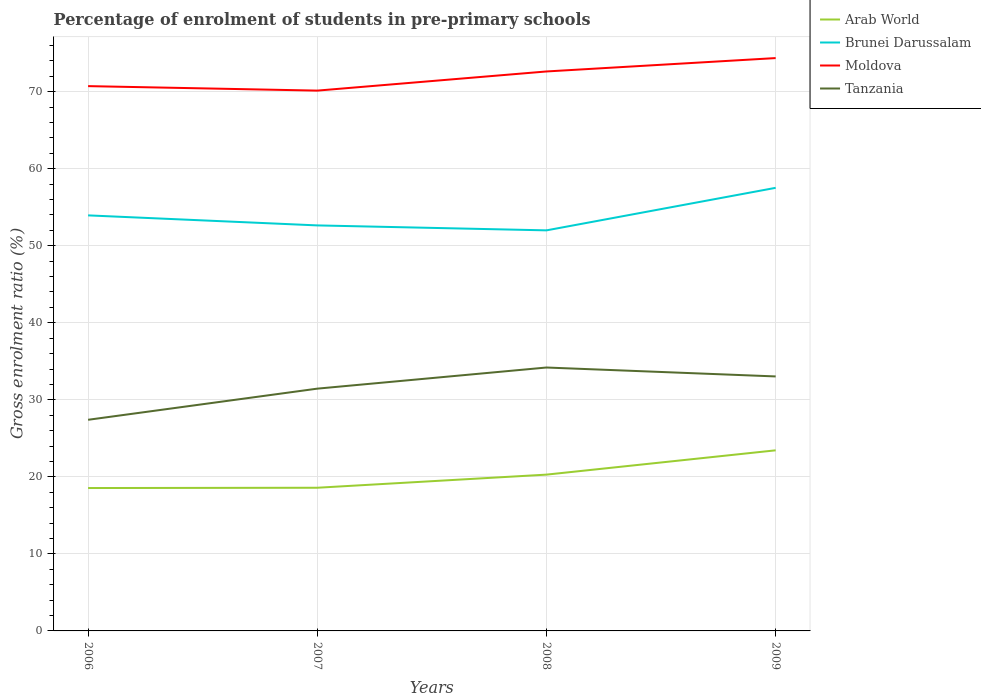Does the line corresponding to Moldova intersect with the line corresponding to Brunei Darussalam?
Your answer should be very brief. No. Is the number of lines equal to the number of legend labels?
Make the answer very short. Yes. Across all years, what is the maximum percentage of students enrolled in pre-primary schools in Arab World?
Provide a short and direct response. 18.55. What is the total percentage of students enrolled in pre-primary schools in Brunei Darussalam in the graph?
Give a very brief answer. 0.64. What is the difference between the highest and the second highest percentage of students enrolled in pre-primary schools in Moldova?
Keep it short and to the point. 4.22. What is the difference between the highest and the lowest percentage of students enrolled in pre-primary schools in Arab World?
Provide a short and direct response. 2. Does the graph contain any zero values?
Your answer should be compact. No. Where does the legend appear in the graph?
Offer a terse response. Top right. How many legend labels are there?
Give a very brief answer. 4. What is the title of the graph?
Offer a terse response. Percentage of enrolment of students in pre-primary schools. What is the label or title of the X-axis?
Ensure brevity in your answer.  Years. What is the Gross enrolment ratio (%) in Arab World in 2006?
Your response must be concise. 18.55. What is the Gross enrolment ratio (%) in Brunei Darussalam in 2006?
Your answer should be compact. 53.94. What is the Gross enrolment ratio (%) in Moldova in 2006?
Provide a succinct answer. 70.72. What is the Gross enrolment ratio (%) of Tanzania in 2006?
Your answer should be very brief. 27.41. What is the Gross enrolment ratio (%) of Arab World in 2007?
Your answer should be very brief. 18.59. What is the Gross enrolment ratio (%) of Brunei Darussalam in 2007?
Your answer should be very brief. 52.64. What is the Gross enrolment ratio (%) of Moldova in 2007?
Offer a very short reply. 70.14. What is the Gross enrolment ratio (%) of Tanzania in 2007?
Keep it short and to the point. 31.45. What is the Gross enrolment ratio (%) in Arab World in 2008?
Your answer should be very brief. 20.29. What is the Gross enrolment ratio (%) of Brunei Darussalam in 2008?
Offer a terse response. 52. What is the Gross enrolment ratio (%) in Moldova in 2008?
Your answer should be very brief. 72.63. What is the Gross enrolment ratio (%) in Tanzania in 2008?
Provide a short and direct response. 34.2. What is the Gross enrolment ratio (%) of Arab World in 2009?
Your answer should be compact. 23.45. What is the Gross enrolment ratio (%) of Brunei Darussalam in 2009?
Keep it short and to the point. 57.52. What is the Gross enrolment ratio (%) in Moldova in 2009?
Offer a terse response. 74.37. What is the Gross enrolment ratio (%) of Tanzania in 2009?
Offer a terse response. 33.04. Across all years, what is the maximum Gross enrolment ratio (%) of Arab World?
Offer a terse response. 23.45. Across all years, what is the maximum Gross enrolment ratio (%) in Brunei Darussalam?
Your response must be concise. 57.52. Across all years, what is the maximum Gross enrolment ratio (%) of Moldova?
Your response must be concise. 74.37. Across all years, what is the maximum Gross enrolment ratio (%) of Tanzania?
Keep it short and to the point. 34.2. Across all years, what is the minimum Gross enrolment ratio (%) of Arab World?
Provide a succinct answer. 18.55. Across all years, what is the minimum Gross enrolment ratio (%) in Brunei Darussalam?
Make the answer very short. 52. Across all years, what is the minimum Gross enrolment ratio (%) of Moldova?
Offer a terse response. 70.14. Across all years, what is the minimum Gross enrolment ratio (%) of Tanzania?
Your answer should be compact. 27.41. What is the total Gross enrolment ratio (%) in Arab World in the graph?
Keep it short and to the point. 80.87. What is the total Gross enrolment ratio (%) in Brunei Darussalam in the graph?
Keep it short and to the point. 216.11. What is the total Gross enrolment ratio (%) of Moldova in the graph?
Ensure brevity in your answer.  287.86. What is the total Gross enrolment ratio (%) of Tanzania in the graph?
Keep it short and to the point. 126.09. What is the difference between the Gross enrolment ratio (%) of Arab World in 2006 and that in 2007?
Give a very brief answer. -0.04. What is the difference between the Gross enrolment ratio (%) of Brunei Darussalam in 2006 and that in 2007?
Provide a succinct answer. 1.3. What is the difference between the Gross enrolment ratio (%) in Moldova in 2006 and that in 2007?
Provide a short and direct response. 0.58. What is the difference between the Gross enrolment ratio (%) of Tanzania in 2006 and that in 2007?
Your response must be concise. -4.04. What is the difference between the Gross enrolment ratio (%) in Arab World in 2006 and that in 2008?
Keep it short and to the point. -1.74. What is the difference between the Gross enrolment ratio (%) of Brunei Darussalam in 2006 and that in 2008?
Provide a short and direct response. 1.94. What is the difference between the Gross enrolment ratio (%) in Moldova in 2006 and that in 2008?
Ensure brevity in your answer.  -1.9. What is the difference between the Gross enrolment ratio (%) in Tanzania in 2006 and that in 2008?
Keep it short and to the point. -6.79. What is the difference between the Gross enrolment ratio (%) of Arab World in 2006 and that in 2009?
Make the answer very short. -4.9. What is the difference between the Gross enrolment ratio (%) in Brunei Darussalam in 2006 and that in 2009?
Your response must be concise. -3.58. What is the difference between the Gross enrolment ratio (%) in Moldova in 2006 and that in 2009?
Offer a terse response. -3.64. What is the difference between the Gross enrolment ratio (%) in Tanzania in 2006 and that in 2009?
Offer a very short reply. -5.63. What is the difference between the Gross enrolment ratio (%) in Arab World in 2007 and that in 2008?
Give a very brief answer. -1.7. What is the difference between the Gross enrolment ratio (%) of Brunei Darussalam in 2007 and that in 2008?
Offer a very short reply. 0.64. What is the difference between the Gross enrolment ratio (%) in Moldova in 2007 and that in 2008?
Give a very brief answer. -2.49. What is the difference between the Gross enrolment ratio (%) in Tanzania in 2007 and that in 2008?
Offer a very short reply. -2.74. What is the difference between the Gross enrolment ratio (%) of Arab World in 2007 and that in 2009?
Your response must be concise. -4.86. What is the difference between the Gross enrolment ratio (%) in Brunei Darussalam in 2007 and that in 2009?
Provide a succinct answer. -4.88. What is the difference between the Gross enrolment ratio (%) in Moldova in 2007 and that in 2009?
Ensure brevity in your answer.  -4.22. What is the difference between the Gross enrolment ratio (%) of Tanzania in 2007 and that in 2009?
Offer a very short reply. -1.59. What is the difference between the Gross enrolment ratio (%) of Arab World in 2008 and that in 2009?
Give a very brief answer. -3.16. What is the difference between the Gross enrolment ratio (%) of Brunei Darussalam in 2008 and that in 2009?
Give a very brief answer. -5.52. What is the difference between the Gross enrolment ratio (%) in Moldova in 2008 and that in 2009?
Provide a short and direct response. -1.74. What is the difference between the Gross enrolment ratio (%) in Tanzania in 2008 and that in 2009?
Keep it short and to the point. 1.16. What is the difference between the Gross enrolment ratio (%) of Arab World in 2006 and the Gross enrolment ratio (%) of Brunei Darussalam in 2007?
Make the answer very short. -34.09. What is the difference between the Gross enrolment ratio (%) of Arab World in 2006 and the Gross enrolment ratio (%) of Moldova in 2007?
Give a very brief answer. -51.59. What is the difference between the Gross enrolment ratio (%) in Arab World in 2006 and the Gross enrolment ratio (%) in Tanzania in 2007?
Your answer should be compact. -12.9. What is the difference between the Gross enrolment ratio (%) of Brunei Darussalam in 2006 and the Gross enrolment ratio (%) of Moldova in 2007?
Keep it short and to the point. -16.2. What is the difference between the Gross enrolment ratio (%) in Brunei Darussalam in 2006 and the Gross enrolment ratio (%) in Tanzania in 2007?
Your answer should be compact. 22.49. What is the difference between the Gross enrolment ratio (%) in Moldova in 2006 and the Gross enrolment ratio (%) in Tanzania in 2007?
Your answer should be very brief. 39.27. What is the difference between the Gross enrolment ratio (%) of Arab World in 2006 and the Gross enrolment ratio (%) of Brunei Darussalam in 2008?
Offer a terse response. -33.45. What is the difference between the Gross enrolment ratio (%) in Arab World in 2006 and the Gross enrolment ratio (%) in Moldova in 2008?
Give a very brief answer. -54.08. What is the difference between the Gross enrolment ratio (%) of Arab World in 2006 and the Gross enrolment ratio (%) of Tanzania in 2008?
Offer a very short reply. -15.65. What is the difference between the Gross enrolment ratio (%) of Brunei Darussalam in 2006 and the Gross enrolment ratio (%) of Moldova in 2008?
Make the answer very short. -18.68. What is the difference between the Gross enrolment ratio (%) of Brunei Darussalam in 2006 and the Gross enrolment ratio (%) of Tanzania in 2008?
Offer a very short reply. 19.75. What is the difference between the Gross enrolment ratio (%) of Moldova in 2006 and the Gross enrolment ratio (%) of Tanzania in 2008?
Provide a short and direct response. 36.53. What is the difference between the Gross enrolment ratio (%) in Arab World in 2006 and the Gross enrolment ratio (%) in Brunei Darussalam in 2009?
Your response must be concise. -38.97. What is the difference between the Gross enrolment ratio (%) of Arab World in 2006 and the Gross enrolment ratio (%) of Moldova in 2009?
Your answer should be very brief. -55.82. What is the difference between the Gross enrolment ratio (%) in Arab World in 2006 and the Gross enrolment ratio (%) in Tanzania in 2009?
Offer a very short reply. -14.49. What is the difference between the Gross enrolment ratio (%) of Brunei Darussalam in 2006 and the Gross enrolment ratio (%) of Moldova in 2009?
Your answer should be very brief. -20.42. What is the difference between the Gross enrolment ratio (%) of Brunei Darussalam in 2006 and the Gross enrolment ratio (%) of Tanzania in 2009?
Provide a succinct answer. 20.91. What is the difference between the Gross enrolment ratio (%) in Moldova in 2006 and the Gross enrolment ratio (%) in Tanzania in 2009?
Keep it short and to the point. 37.69. What is the difference between the Gross enrolment ratio (%) in Arab World in 2007 and the Gross enrolment ratio (%) in Brunei Darussalam in 2008?
Ensure brevity in your answer.  -33.41. What is the difference between the Gross enrolment ratio (%) of Arab World in 2007 and the Gross enrolment ratio (%) of Moldova in 2008?
Ensure brevity in your answer.  -54.04. What is the difference between the Gross enrolment ratio (%) in Arab World in 2007 and the Gross enrolment ratio (%) in Tanzania in 2008?
Your response must be concise. -15.61. What is the difference between the Gross enrolment ratio (%) in Brunei Darussalam in 2007 and the Gross enrolment ratio (%) in Moldova in 2008?
Your response must be concise. -19.98. What is the difference between the Gross enrolment ratio (%) in Brunei Darussalam in 2007 and the Gross enrolment ratio (%) in Tanzania in 2008?
Ensure brevity in your answer.  18.45. What is the difference between the Gross enrolment ratio (%) in Moldova in 2007 and the Gross enrolment ratio (%) in Tanzania in 2008?
Ensure brevity in your answer.  35.95. What is the difference between the Gross enrolment ratio (%) in Arab World in 2007 and the Gross enrolment ratio (%) in Brunei Darussalam in 2009?
Give a very brief answer. -38.93. What is the difference between the Gross enrolment ratio (%) in Arab World in 2007 and the Gross enrolment ratio (%) in Moldova in 2009?
Provide a succinct answer. -55.78. What is the difference between the Gross enrolment ratio (%) in Arab World in 2007 and the Gross enrolment ratio (%) in Tanzania in 2009?
Keep it short and to the point. -14.45. What is the difference between the Gross enrolment ratio (%) of Brunei Darussalam in 2007 and the Gross enrolment ratio (%) of Moldova in 2009?
Provide a succinct answer. -21.72. What is the difference between the Gross enrolment ratio (%) in Brunei Darussalam in 2007 and the Gross enrolment ratio (%) in Tanzania in 2009?
Offer a terse response. 19.61. What is the difference between the Gross enrolment ratio (%) of Moldova in 2007 and the Gross enrolment ratio (%) of Tanzania in 2009?
Provide a short and direct response. 37.1. What is the difference between the Gross enrolment ratio (%) of Arab World in 2008 and the Gross enrolment ratio (%) of Brunei Darussalam in 2009?
Give a very brief answer. -37.23. What is the difference between the Gross enrolment ratio (%) in Arab World in 2008 and the Gross enrolment ratio (%) in Moldova in 2009?
Offer a terse response. -54.08. What is the difference between the Gross enrolment ratio (%) in Arab World in 2008 and the Gross enrolment ratio (%) in Tanzania in 2009?
Ensure brevity in your answer.  -12.75. What is the difference between the Gross enrolment ratio (%) of Brunei Darussalam in 2008 and the Gross enrolment ratio (%) of Moldova in 2009?
Provide a short and direct response. -22.37. What is the difference between the Gross enrolment ratio (%) of Brunei Darussalam in 2008 and the Gross enrolment ratio (%) of Tanzania in 2009?
Provide a succinct answer. 18.96. What is the difference between the Gross enrolment ratio (%) of Moldova in 2008 and the Gross enrolment ratio (%) of Tanzania in 2009?
Your answer should be very brief. 39.59. What is the average Gross enrolment ratio (%) in Arab World per year?
Offer a terse response. 20.22. What is the average Gross enrolment ratio (%) of Brunei Darussalam per year?
Offer a very short reply. 54.03. What is the average Gross enrolment ratio (%) in Moldova per year?
Your response must be concise. 71.97. What is the average Gross enrolment ratio (%) in Tanzania per year?
Offer a terse response. 31.52. In the year 2006, what is the difference between the Gross enrolment ratio (%) of Arab World and Gross enrolment ratio (%) of Brunei Darussalam?
Your answer should be very brief. -35.4. In the year 2006, what is the difference between the Gross enrolment ratio (%) of Arab World and Gross enrolment ratio (%) of Moldova?
Make the answer very short. -52.18. In the year 2006, what is the difference between the Gross enrolment ratio (%) in Arab World and Gross enrolment ratio (%) in Tanzania?
Your response must be concise. -8.86. In the year 2006, what is the difference between the Gross enrolment ratio (%) of Brunei Darussalam and Gross enrolment ratio (%) of Moldova?
Ensure brevity in your answer.  -16.78. In the year 2006, what is the difference between the Gross enrolment ratio (%) of Brunei Darussalam and Gross enrolment ratio (%) of Tanzania?
Make the answer very short. 26.54. In the year 2006, what is the difference between the Gross enrolment ratio (%) in Moldova and Gross enrolment ratio (%) in Tanzania?
Ensure brevity in your answer.  43.32. In the year 2007, what is the difference between the Gross enrolment ratio (%) in Arab World and Gross enrolment ratio (%) in Brunei Darussalam?
Offer a very short reply. -34.06. In the year 2007, what is the difference between the Gross enrolment ratio (%) in Arab World and Gross enrolment ratio (%) in Moldova?
Your response must be concise. -51.55. In the year 2007, what is the difference between the Gross enrolment ratio (%) in Arab World and Gross enrolment ratio (%) in Tanzania?
Offer a very short reply. -12.86. In the year 2007, what is the difference between the Gross enrolment ratio (%) in Brunei Darussalam and Gross enrolment ratio (%) in Moldova?
Make the answer very short. -17.5. In the year 2007, what is the difference between the Gross enrolment ratio (%) of Brunei Darussalam and Gross enrolment ratio (%) of Tanzania?
Keep it short and to the point. 21.19. In the year 2007, what is the difference between the Gross enrolment ratio (%) of Moldova and Gross enrolment ratio (%) of Tanzania?
Offer a terse response. 38.69. In the year 2008, what is the difference between the Gross enrolment ratio (%) of Arab World and Gross enrolment ratio (%) of Brunei Darussalam?
Keep it short and to the point. -31.71. In the year 2008, what is the difference between the Gross enrolment ratio (%) of Arab World and Gross enrolment ratio (%) of Moldova?
Ensure brevity in your answer.  -52.34. In the year 2008, what is the difference between the Gross enrolment ratio (%) in Arab World and Gross enrolment ratio (%) in Tanzania?
Offer a terse response. -13.91. In the year 2008, what is the difference between the Gross enrolment ratio (%) of Brunei Darussalam and Gross enrolment ratio (%) of Moldova?
Your answer should be very brief. -20.63. In the year 2008, what is the difference between the Gross enrolment ratio (%) in Brunei Darussalam and Gross enrolment ratio (%) in Tanzania?
Keep it short and to the point. 17.8. In the year 2008, what is the difference between the Gross enrolment ratio (%) in Moldova and Gross enrolment ratio (%) in Tanzania?
Your answer should be very brief. 38.43. In the year 2009, what is the difference between the Gross enrolment ratio (%) in Arab World and Gross enrolment ratio (%) in Brunei Darussalam?
Your answer should be compact. -34.08. In the year 2009, what is the difference between the Gross enrolment ratio (%) of Arab World and Gross enrolment ratio (%) of Moldova?
Provide a succinct answer. -50.92. In the year 2009, what is the difference between the Gross enrolment ratio (%) in Arab World and Gross enrolment ratio (%) in Tanzania?
Offer a terse response. -9.59. In the year 2009, what is the difference between the Gross enrolment ratio (%) of Brunei Darussalam and Gross enrolment ratio (%) of Moldova?
Keep it short and to the point. -16.84. In the year 2009, what is the difference between the Gross enrolment ratio (%) in Brunei Darussalam and Gross enrolment ratio (%) in Tanzania?
Provide a short and direct response. 24.48. In the year 2009, what is the difference between the Gross enrolment ratio (%) in Moldova and Gross enrolment ratio (%) in Tanzania?
Your response must be concise. 41.33. What is the ratio of the Gross enrolment ratio (%) in Brunei Darussalam in 2006 to that in 2007?
Ensure brevity in your answer.  1.02. What is the ratio of the Gross enrolment ratio (%) in Moldova in 2006 to that in 2007?
Your answer should be compact. 1.01. What is the ratio of the Gross enrolment ratio (%) of Tanzania in 2006 to that in 2007?
Provide a short and direct response. 0.87. What is the ratio of the Gross enrolment ratio (%) of Arab World in 2006 to that in 2008?
Keep it short and to the point. 0.91. What is the ratio of the Gross enrolment ratio (%) in Brunei Darussalam in 2006 to that in 2008?
Offer a terse response. 1.04. What is the ratio of the Gross enrolment ratio (%) in Moldova in 2006 to that in 2008?
Your answer should be very brief. 0.97. What is the ratio of the Gross enrolment ratio (%) of Tanzania in 2006 to that in 2008?
Your response must be concise. 0.8. What is the ratio of the Gross enrolment ratio (%) of Arab World in 2006 to that in 2009?
Ensure brevity in your answer.  0.79. What is the ratio of the Gross enrolment ratio (%) of Brunei Darussalam in 2006 to that in 2009?
Your answer should be compact. 0.94. What is the ratio of the Gross enrolment ratio (%) of Moldova in 2006 to that in 2009?
Make the answer very short. 0.95. What is the ratio of the Gross enrolment ratio (%) in Tanzania in 2006 to that in 2009?
Your response must be concise. 0.83. What is the ratio of the Gross enrolment ratio (%) in Arab World in 2007 to that in 2008?
Keep it short and to the point. 0.92. What is the ratio of the Gross enrolment ratio (%) in Brunei Darussalam in 2007 to that in 2008?
Give a very brief answer. 1.01. What is the ratio of the Gross enrolment ratio (%) of Moldova in 2007 to that in 2008?
Keep it short and to the point. 0.97. What is the ratio of the Gross enrolment ratio (%) in Tanzania in 2007 to that in 2008?
Your response must be concise. 0.92. What is the ratio of the Gross enrolment ratio (%) of Arab World in 2007 to that in 2009?
Offer a very short reply. 0.79. What is the ratio of the Gross enrolment ratio (%) in Brunei Darussalam in 2007 to that in 2009?
Ensure brevity in your answer.  0.92. What is the ratio of the Gross enrolment ratio (%) of Moldova in 2007 to that in 2009?
Offer a very short reply. 0.94. What is the ratio of the Gross enrolment ratio (%) of Tanzania in 2007 to that in 2009?
Give a very brief answer. 0.95. What is the ratio of the Gross enrolment ratio (%) of Arab World in 2008 to that in 2009?
Offer a terse response. 0.87. What is the ratio of the Gross enrolment ratio (%) in Brunei Darussalam in 2008 to that in 2009?
Offer a very short reply. 0.9. What is the ratio of the Gross enrolment ratio (%) in Moldova in 2008 to that in 2009?
Make the answer very short. 0.98. What is the ratio of the Gross enrolment ratio (%) in Tanzania in 2008 to that in 2009?
Provide a short and direct response. 1.04. What is the difference between the highest and the second highest Gross enrolment ratio (%) in Arab World?
Your response must be concise. 3.16. What is the difference between the highest and the second highest Gross enrolment ratio (%) of Brunei Darussalam?
Your answer should be compact. 3.58. What is the difference between the highest and the second highest Gross enrolment ratio (%) in Moldova?
Offer a terse response. 1.74. What is the difference between the highest and the second highest Gross enrolment ratio (%) in Tanzania?
Give a very brief answer. 1.16. What is the difference between the highest and the lowest Gross enrolment ratio (%) in Arab World?
Keep it short and to the point. 4.9. What is the difference between the highest and the lowest Gross enrolment ratio (%) of Brunei Darussalam?
Keep it short and to the point. 5.52. What is the difference between the highest and the lowest Gross enrolment ratio (%) in Moldova?
Provide a succinct answer. 4.22. What is the difference between the highest and the lowest Gross enrolment ratio (%) of Tanzania?
Keep it short and to the point. 6.79. 